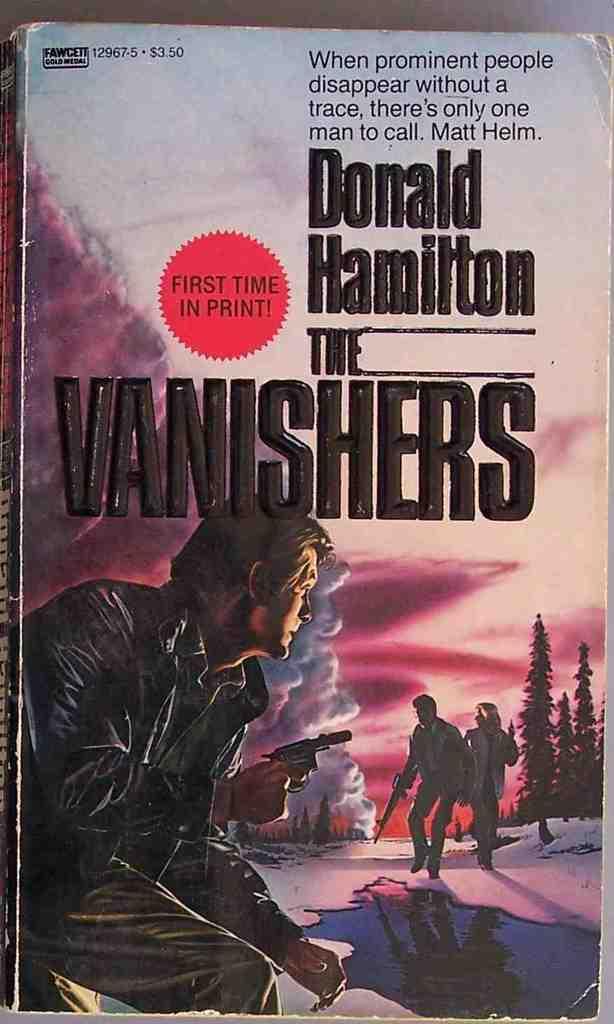Who is the author of the vanishers?
Ensure brevity in your answer.  Donald hamilton. 